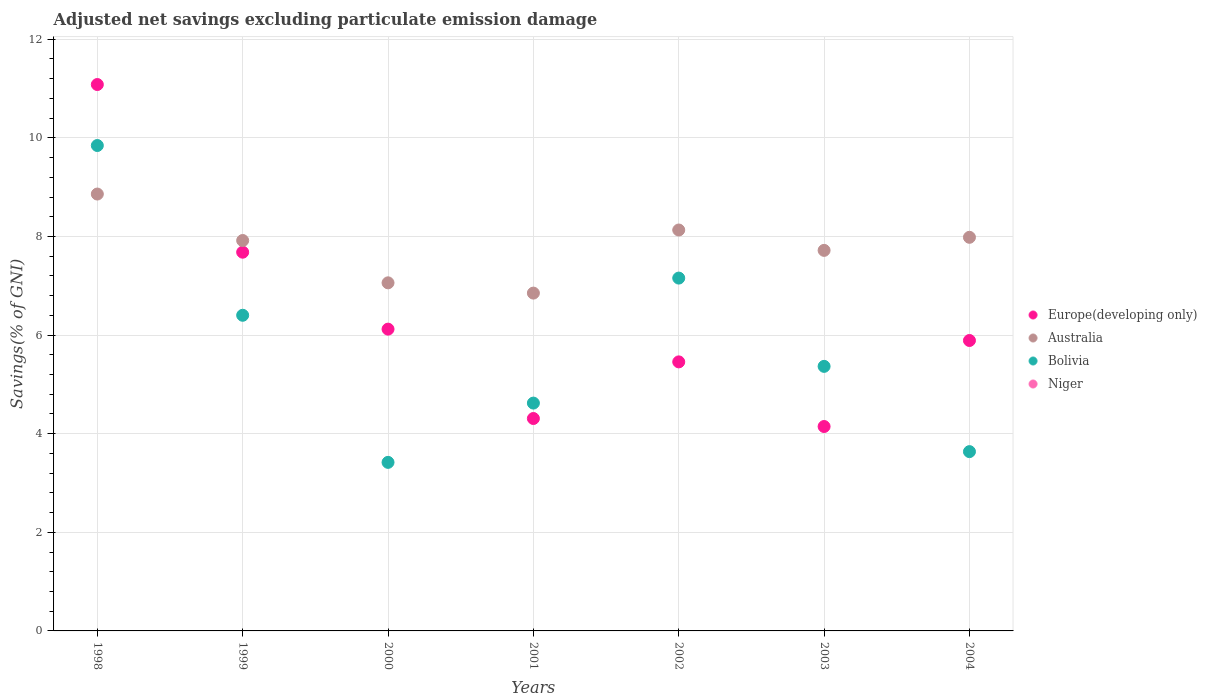How many different coloured dotlines are there?
Ensure brevity in your answer.  3. Is the number of dotlines equal to the number of legend labels?
Provide a succinct answer. No. What is the adjusted net savings in Bolivia in 2002?
Your answer should be compact. 7.16. Across all years, what is the maximum adjusted net savings in Bolivia?
Give a very brief answer. 9.85. Across all years, what is the minimum adjusted net savings in Bolivia?
Offer a terse response. 3.42. In which year was the adjusted net savings in Europe(developing only) maximum?
Your answer should be compact. 1998. What is the difference between the adjusted net savings in Bolivia in 1998 and that in 1999?
Offer a very short reply. 3.44. What is the difference between the adjusted net savings in Europe(developing only) in 1998 and the adjusted net savings in Bolivia in 2001?
Your response must be concise. 6.46. What is the average adjusted net savings in Europe(developing only) per year?
Your answer should be very brief. 6.38. In the year 2001, what is the difference between the adjusted net savings in Bolivia and adjusted net savings in Europe(developing only)?
Offer a very short reply. 0.31. What is the ratio of the adjusted net savings in Australia in 1999 to that in 2004?
Ensure brevity in your answer.  0.99. Is the adjusted net savings in Europe(developing only) in 2000 less than that in 2002?
Offer a very short reply. No. Is the difference between the adjusted net savings in Bolivia in 1998 and 2002 greater than the difference between the adjusted net savings in Europe(developing only) in 1998 and 2002?
Offer a terse response. No. What is the difference between the highest and the second highest adjusted net savings in Bolivia?
Offer a very short reply. 2.69. What is the difference between the highest and the lowest adjusted net savings in Europe(developing only)?
Give a very brief answer. 6.94. Does the adjusted net savings in Europe(developing only) monotonically increase over the years?
Make the answer very short. No. Is the adjusted net savings in Niger strictly greater than the adjusted net savings in Bolivia over the years?
Your response must be concise. No. How many dotlines are there?
Offer a terse response. 3. How many years are there in the graph?
Offer a terse response. 7. Does the graph contain any zero values?
Ensure brevity in your answer.  Yes. Where does the legend appear in the graph?
Your response must be concise. Center right. How many legend labels are there?
Provide a succinct answer. 4. How are the legend labels stacked?
Give a very brief answer. Vertical. What is the title of the graph?
Offer a very short reply. Adjusted net savings excluding particulate emission damage. What is the label or title of the Y-axis?
Provide a succinct answer. Savings(% of GNI). What is the Savings(% of GNI) in Europe(developing only) in 1998?
Provide a succinct answer. 11.08. What is the Savings(% of GNI) of Australia in 1998?
Provide a short and direct response. 8.86. What is the Savings(% of GNI) of Bolivia in 1998?
Make the answer very short. 9.85. What is the Savings(% of GNI) in Europe(developing only) in 1999?
Offer a terse response. 7.68. What is the Savings(% of GNI) in Australia in 1999?
Offer a very short reply. 7.92. What is the Savings(% of GNI) of Bolivia in 1999?
Provide a short and direct response. 6.4. What is the Savings(% of GNI) in Niger in 1999?
Make the answer very short. 0. What is the Savings(% of GNI) in Europe(developing only) in 2000?
Offer a terse response. 6.12. What is the Savings(% of GNI) in Australia in 2000?
Make the answer very short. 7.06. What is the Savings(% of GNI) of Bolivia in 2000?
Make the answer very short. 3.42. What is the Savings(% of GNI) of Niger in 2000?
Your response must be concise. 0. What is the Savings(% of GNI) in Europe(developing only) in 2001?
Keep it short and to the point. 4.31. What is the Savings(% of GNI) in Australia in 2001?
Your response must be concise. 6.85. What is the Savings(% of GNI) of Bolivia in 2001?
Offer a very short reply. 4.62. What is the Savings(% of GNI) of Europe(developing only) in 2002?
Keep it short and to the point. 5.46. What is the Savings(% of GNI) of Australia in 2002?
Your answer should be compact. 8.13. What is the Savings(% of GNI) in Bolivia in 2002?
Your answer should be compact. 7.16. What is the Savings(% of GNI) in Niger in 2002?
Your answer should be very brief. 0. What is the Savings(% of GNI) in Europe(developing only) in 2003?
Offer a very short reply. 4.15. What is the Savings(% of GNI) of Australia in 2003?
Your answer should be very brief. 7.72. What is the Savings(% of GNI) in Bolivia in 2003?
Give a very brief answer. 5.37. What is the Savings(% of GNI) of Niger in 2003?
Provide a short and direct response. 0. What is the Savings(% of GNI) in Europe(developing only) in 2004?
Give a very brief answer. 5.89. What is the Savings(% of GNI) of Australia in 2004?
Keep it short and to the point. 7.98. What is the Savings(% of GNI) of Bolivia in 2004?
Provide a succinct answer. 3.64. What is the Savings(% of GNI) in Niger in 2004?
Provide a succinct answer. 0. Across all years, what is the maximum Savings(% of GNI) in Europe(developing only)?
Your response must be concise. 11.08. Across all years, what is the maximum Savings(% of GNI) in Australia?
Your answer should be very brief. 8.86. Across all years, what is the maximum Savings(% of GNI) of Bolivia?
Keep it short and to the point. 9.85. Across all years, what is the minimum Savings(% of GNI) of Europe(developing only)?
Your response must be concise. 4.15. Across all years, what is the minimum Savings(% of GNI) in Australia?
Your answer should be compact. 6.85. Across all years, what is the minimum Savings(% of GNI) in Bolivia?
Provide a short and direct response. 3.42. What is the total Savings(% of GNI) in Europe(developing only) in the graph?
Make the answer very short. 44.69. What is the total Savings(% of GNI) of Australia in the graph?
Your answer should be compact. 54.52. What is the total Savings(% of GNI) in Bolivia in the graph?
Make the answer very short. 40.45. What is the difference between the Savings(% of GNI) in Europe(developing only) in 1998 and that in 1999?
Your answer should be compact. 3.4. What is the difference between the Savings(% of GNI) of Australia in 1998 and that in 1999?
Offer a very short reply. 0.94. What is the difference between the Savings(% of GNI) of Bolivia in 1998 and that in 1999?
Ensure brevity in your answer.  3.44. What is the difference between the Savings(% of GNI) of Europe(developing only) in 1998 and that in 2000?
Your answer should be compact. 4.96. What is the difference between the Savings(% of GNI) in Australia in 1998 and that in 2000?
Give a very brief answer. 1.8. What is the difference between the Savings(% of GNI) in Bolivia in 1998 and that in 2000?
Give a very brief answer. 6.43. What is the difference between the Savings(% of GNI) in Europe(developing only) in 1998 and that in 2001?
Give a very brief answer. 6.77. What is the difference between the Savings(% of GNI) of Australia in 1998 and that in 2001?
Offer a very short reply. 2.01. What is the difference between the Savings(% of GNI) of Bolivia in 1998 and that in 2001?
Give a very brief answer. 5.22. What is the difference between the Savings(% of GNI) in Europe(developing only) in 1998 and that in 2002?
Ensure brevity in your answer.  5.63. What is the difference between the Savings(% of GNI) in Australia in 1998 and that in 2002?
Your answer should be very brief. 0.73. What is the difference between the Savings(% of GNI) of Bolivia in 1998 and that in 2002?
Make the answer very short. 2.69. What is the difference between the Savings(% of GNI) in Europe(developing only) in 1998 and that in 2003?
Your answer should be very brief. 6.94. What is the difference between the Savings(% of GNI) in Australia in 1998 and that in 2003?
Your answer should be compact. 1.14. What is the difference between the Savings(% of GNI) in Bolivia in 1998 and that in 2003?
Provide a succinct answer. 4.48. What is the difference between the Savings(% of GNI) in Europe(developing only) in 1998 and that in 2004?
Your answer should be compact. 5.19. What is the difference between the Savings(% of GNI) of Australia in 1998 and that in 2004?
Give a very brief answer. 0.88. What is the difference between the Savings(% of GNI) of Bolivia in 1998 and that in 2004?
Ensure brevity in your answer.  6.21. What is the difference between the Savings(% of GNI) of Europe(developing only) in 1999 and that in 2000?
Keep it short and to the point. 1.56. What is the difference between the Savings(% of GNI) of Australia in 1999 and that in 2000?
Provide a succinct answer. 0.86. What is the difference between the Savings(% of GNI) of Bolivia in 1999 and that in 2000?
Your answer should be very brief. 2.98. What is the difference between the Savings(% of GNI) of Europe(developing only) in 1999 and that in 2001?
Provide a succinct answer. 3.37. What is the difference between the Savings(% of GNI) in Australia in 1999 and that in 2001?
Keep it short and to the point. 1.07. What is the difference between the Savings(% of GNI) in Bolivia in 1999 and that in 2001?
Your answer should be very brief. 1.78. What is the difference between the Savings(% of GNI) of Europe(developing only) in 1999 and that in 2002?
Provide a short and direct response. 2.22. What is the difference between the Savings(% of GNI) in Australia in 1999 and that in 2002?
Make the answer very short. -0.21. What is the difference between the Savings(% of GNI) in Bolivia in 1999 and that in 2002?
Offer a very short reply. -0.75. What is the difference between the Savings(% of GNI) in Europe(developing only) in 1999 and that in 2003?
Keep it short and to the point. 3.54. What is the difference between the Savings(% of GNI) of Australia in 1999 and that in 2003?
Your answer should be very brief. 0.2. What is the difference between the Savings(% of GNI) of Bolivia in 1999 and that in 2003?
Your answer should be very brief. 1.04. What is the difference between the Savings(% of GNI) of Europe(developing only) in 1999 and that in 2004?
Offer a terse response. 1.79. What is the difference between the Savings(% of GNI) of Australia in 1999 and that in 2004?
Provide a succinct answer. -0.06. What is the difference between the Savings(% of GNI) in Bolivia in 1999 and that in 2004?
Give a very brief answer. 2.77. What is the difference between the Savings(% of GNI) of Europe(developing only) in 2000 and that in 2001?
Provide a succinct answer. 1.81. What is the difference between the Savings(% of GNI) of Australia in 2000 and that in 2001?
Offer a very short reply. 0.21. What is the difference between the Savings(% of GNI) in Bolivia in 2000 and that in 2001?
Offer a very short reply. -1.2. What is the difference between the Savings(% of GNI) of Europe(developing only) in 2000 and that in 2002?
Your response must be concise. 0.66. What is the difference between the Savings(% of GNI) in Australia in 2000 and that in 2002?
Ensure brevity in your answer.  -1.07. What is the difference between the Savings(% of GNI) of Bolivia in 2000 and that in 2002?
Your response must be concise. -3.74. What is the difference between the Savings(% of GNI) of Europe(developing only) in 2000 and that in 2003?
Provide a succinct answer. 1.98. What is the difference between the Savings(% of GNI) in Australia in 2000 and that in 2003?
Your answer should be very brief. -0.66. What is the difference between the Savings(% of GNI) of Bolivia in 2000 and that in 2003?
Provide a succinct answer. -1.95. What is the difference between the Savings(% of GNI) in Europe(developing only) in 2000 and that in 2004?
Your response must be concise. 0.23. What is the difference between the Savings(% of GNI) in Australia in 2000 and that in 2004?
Make the answer very short. -0.92. What is the difference between the Savings(% of GNI) in Bolivia in 2000 and that in 2004?
Your response must be concise. -0.22. What is the difference between the Savings(% of GNI) in Europe(developing only) in 2001 and that in 2002?
Ensure brevity in your answer.  -1.15. What is the difference between the Savings(% of GNI) of Australia in 2001 and that in 2002?
Keep it short and to the point. -1.28. What is the difference between the Savings(% of GNI) in Bolivia in 2001 and that in 2002?
Offer a terse response. -2.54. What is the difference between the Savings(% of GNI) of Europe(developing only) in 2001 and that in 2003?
Keep it short and to the point. 0.16. What is the difference between the Savings(% of GNI) of Australia in 2001 and that in 2003?
Offer a terse response. -0.87. What is the difference between the Savings(% of GNI) of Bolivia in 2001 and that in 2003?
Your answer should be very brief. -0.74. What is the difference between the Savings(% of GNI) of Europe(developing only) in 2001 and that in 2004?
Make the answer very short. -1.58. What is the difference between the Savings(% of GNI) in Australia in 2001 and that in 2004?
Provide a short and direct response. -1.13. What is the difference between the Savings(% of GNI) in Bolivia in 2001 and that in 2004?
Provide a short and direct response. 0.98. What is the difference between the Savings(% of GNI) of Europe(developing only) in 2002 and that in 2003?
Provide a short and direct response. 1.31. What is the difference between the Savings(% of GNI) in Australia in 2002 and that in 2003?
Keep it short and to the point. 0.41. What is the difference between the Savings(% of GNI) in Bolivia in 2002 and that in 2003?
Your answer should be very brief. 1.79. What is the difference between the Savings(% of GNI) in Europe(developing only) in 2002 and that in 2004?
Your answer should be compact. -0.43. What is the difference between the Savings(% of GNI) of Australia in 2002 and that in 2004?
Offer a terse response. 0.15. What is the difference between the Savings(% of GNI) in Bolivia in 2002 and that in 2004?
Your response must be concise. 3.52. What is the difference between the Savings(% of GNI) in Europe(developing only) in 2003 and that in 2004?
Make the answer very short. -1.74. What is the difference between the Savings(% of GNI) of Australia in 2003 and that in 2004?
Provide a short and direct response. -0.27. What is the difference between the Savings(% of GNI) of Bolivia in 2003 and that in 2004?
Your answer should be compact. 1.73. What is the difference between the Savings(% of GNI) of Europe(developing only) in 1998 and the Savings(% of GNI) of Australia in 1999?
Provide a short and direct response. 3.16. What is the difference between the Savings(% of GNI) of Europe(developing only) in 1998 and the Savings(% of GNI) of Bolivia in 1999?
Offer a very short reply. 4.68. What is the difference between the Savings(% of GNI) of Australia in 1998 and the Savings(% of GNI) of Bolivia in 1999?
Your answer should be compact. 2.46. What is the difference between the Savings(% of GNI) in Europe(developing only) in 1998 and the Savings(% of GNI) in Australia in 2000?
Keep it short and to the point. 4.02. What is the difference between the Savings(% of GNI) in Europe(developing only) in 1998 and the Savings(% of GNI) in Bolivia in 2000?
Your answer should be very brief. 7.66. What is the difference between the Savings(% of GNI) of Australia in 1998 and the Savings(% of GNI) of Bolivia in 2000?
Keep it short and to the point. 5.44. What is the difference between the Savings(% of GNI) of Europe(developing only) in 1998 and the Savings(% of GNI) of Australia in 2001?
Offer a very short reply. 4.23. What is the difference between the Savings(% of GNI) in Europe(developing only) in 1998 and the Savings(% of GNI) in Bolivia in 2001?
Provide a succinct answer. 6.46. What is the difference between the Savings(% of GNI) in Australia in 1998 and the Savings(% of GNI) in Bolivia in 2001?
Keep it short and to the point. 4.24. What is the difference between the Savings(% of GNI) of Europe(developing only) in 1998 and the Savings(% of GNI) of Australia in 2002?
Ensure brevity in your answer.  2.95. What is the difference between the Savings(% of GNI) of Europe(developing only) in 1998 and the Savings(% of GNI) of Bolivia in 2002?
Keep it short and to the point. 3.93. What is the difference between the Savings(% of GNI) of Australia in 1998 and the Savings(% of GNI) of Bolivia in 2002?
Your answer should be very brief. 1.7. What is the difference between the Savings(% of GNI) of Europe(developing only) in 1998 and the Savings(% of GNI) of Australia in 2003?
Provide a short and direct response. 3.36. What is the difference between the Savings(% of GNI) of Europe(developing only) in 1998 and the Savings(% of GNI) of Bolivia in 2003?
Your answer should be very brief. 5.72. What is the difference between the Savings(% of GNI) of Australia in 1998 and the Savings(% of GNI) of Bolivia in 2003?
Keep it short and to the point. 3.5. What is the difference between the Savings(% of GNI) of Europe(developing only) in 1998 and the Savings(% of GNI) of Australia in 2004?
Provide a short and direct response. 3.1. What is the difference between the Savings(% of GNI) of Europe(developing only) in 1998 and the Savings(% of GNI) of Bolivia in 2004?
Offer a very short reply. 7.45. What is the difference between the Savings(% of GNI) in Australia in 1998 and the Savings(% of GNI) in Bolivia in 2004?
Make the answer very short. 5.22. What is the difference between the Savings(% of GNI) of Europe(developing only) in 1999 and the Savings(% of GNI) of Australia in 2000?
Keep it short and to the point. 0.62. What is the difference between the Savings(% of GNI) of Europe(developing only) in 1999 and the Savings(% of GNI) of Bolivia in 2000?
Offer a very short reply. 4.26. What is the difference between the Savings(% of GNI) in Australia in 1999 and the Savings(% of GNI) in Bolivia in 2000?
Your response must be concise. 4.5. What is the difference between the Savings(% of GNI) in Europe(developing only) in 1999 and the Savings(% of GNI) in Australia in 2001?
Ensure brevity in your answer.  0.83. What is the difference between the Savings(% of GNI) in Europe(developing only) in 1999 and the Savings(% of GNI) in Bolivia in 2001?
Make the answer very short. 3.06. What is the difference between the Savings(% of GNI) of Australia in 1999 and the Savings(% of GNI) of Bolivia in 2001?
Keep it short and to the point. 3.3. What is the difference between the Savings(% of GNI) of Europe(developing only) in 1999 and the Savings(% of GNI) of Australia in 2002?
Your response must be concise. -0.45. What is the difference between the Savings(% of GNI) in Europe(developing only) in 1999 and the Savings(% of GNI) in Bolivia in 2002?
Provide a short and direct response. 0.53. What is the difference between the Savings(% of GNI) in Australia in 1999 and the Savings(% of GNI) in Bolivia in 2002?
Keep it short and to the point. 0.76. What is the difference between the Savings(% of GNI) of Europe(developing only) in 1999 and the Savings(% of GNI) of Australia in 2003?
Your answer should be very brief. -0.04. What is the difference between the Savings(% of GNI) in Europe(developing only) in 1999 and the Savings(% of GNI) in Bolivia in 2003?
Provide a succinct answer. 2.32. What is the difference between the Savings(% of GNI) in Australia in 1999 and the Savings(% of GNI) in Bolivia in 2003?
Your answer should be compact. 2.55. What is the difference between the Savings(% of GNI) of Europe(developing only) in 1999 and the Savings(% of GNI) of Australia in 2004?
Offer a terse response. -0.3. What is the difference between the Savings(% of GNI) in Europe(developing only) in 1999 and the Savings(% of GNI) in Bolivia in 2004?
Keep it short and to the point. 4.04. What is the difference between the Savings(% of GNI) of Australia in 1999 and the Savings(% of GNI) of Bolivia in 2004?
Your response must be concise. 4.28. What is the difference between the Savings(% of GNI) of Europe(developing only) in 2000 and the Savings(% of GNI) of Australia in 2001?
Your response must be concise. -0.73. What is the difference between the Savings(% of GNI) of Europe(developing only) in 2000 and the Savings(% of GNI) of Bolivia in 2001?
Offer a terse response. 1.5. What is the difference between the Savings(% of GNI) of Australia in 2000 and the Savings(% of GNI) of Bolivia in 2001?
Your answer should be compact. 2.44. What is the difference between the Savings(% of GNI) in Europe(developing only) in 2000 and the Savings(% of GNI) in Australia in 2002?
Keep it short and to the point. -2.01. What is the difference between the Savings(% of GNI) of Europe(developing only) in 2000 and the Savings(% of GNI) of Bolivia in 2002?
Your answer should be very brief. -1.04. What is the difference between the Savings(% of GNI) in Australia in 2000 and the Savings(% of GNI) in Bolivia in 2002?
Offer a terse response. -0.1. What is the difference between the Savings(% of GNI) of Europe(developing only) in 2000 and the Savings(% of GNI) of Australia in 2003?
Provide a succinct answer. -1.6. What is the difference between the Savings(% of GNI) of Europe(developing only) in 2000 and the Savings(% of GNI) of Bolivia in 2003?
Provide a short and direct response. 0.76. What is the difference between the Savings(% of GNI) in Australia in 2000 and the Savings(% of GNI) in Bolivia in 2003?
Your answer should be compact. 1.69. What is the difference between the Savings(% of GNI) of Europe(developing only) in 2000 and the Savings(% of GNI) of Australia in 2004?
Your response must be concise. -1.86. What is the difference between the Savings(% of GNI) in Europe(developing only) in 2000 and the Savings(% of GNI) in Bolivia in 2004?
Offer a terse response. 2.48. What is the difference between the Savings(% of GNI) of Australia in 2000 and the Savings(% of GNI) of Bolivia in 2004?
Your answer should be compact. 3.42. What is the difference between the Savings(% of GNI) of Europe(developing only) in 2001 and the Savings(% of GNI) of Australia in 2002?
Give a very brief answer. -3.82. What is the difference between the Savings(% of GNI) in Europe(developing only) in 2001 and the Savings(% of GNI) in Bolivia in 2002?
Your response must be concise. -2.85. What is the difference between the Savings(% of GNI) of Australia in 2001 and the Savings(% of GNI) of Bolivia in 2002?
Ensure brevity in your answer.  -0.3. What is the difference between the Savings(% of GNI) of Europe(developing only) in 2001 and the Savings(% of GNI) of Australia in 2003?
Ensure brevity in your answer.  -3.41. What is the difference between the Savings(% of GNI) in Europe(developing only) in 2001 and the Savings(% of GNI) in Bolivia in 2003?
Make the answer very short. -1.06. What is the difference between the Savings(% of GNI) in Australia in 2001 and the Savings(% of GNI) in Bolivia in 2003?
Make the answer very short. 1.49. What is the difference between the Savings(% of GNI) of Europe(developing only) in 2001 and the Savings(% of GNI) of Australia in 2004?
Keep it short and to the point. -3.67. What is the difference between the Savings(% of GNI) of Europe(developing only) in 2001 and the Savings(% of GNI) of Bolivia in 2004?
Offer a terse response. 0.67. What is the difference between the Savings(% of GNI) in Australia in 2001 and the Savings(% of GNI) in Bolivia in 2004?
Provide a succinct answer. 3.22. What is the difference between the Savings(% of GNI) in Europe(developing only) in 2002 and the Savings(% of GNI) in Australia in 2003?
Offer a very short reply. -2.26. What is the difference between the Savings(% of GNI) of Europe(developing only) in 2002 and the Savings(% of GNI) of Bolivia in 2003?
Provide a succinct answer. 0.09. What is the difference between the Savings(% of GNI) of Australia in 2002 and the Savings(% of GNI) of Bolivia in 2003?
Your answer should be very brief. 2.77. What is the difference between the Savings(% of GNI) in Europe(developing only) in 2002 and the Savings(% of GNI) in Australia in 2004?
Make the answer very short. -2.53. What is the difference between the Savings(% of GNI) in Europe(developing only) in 2002 and the Savings(% of GNI) in Bolivia in 2004?
Offer a very short reply. 1.82. What is the difference between the Savings(% of GNI) of Australia in 2002 and the Savings(% of GNI) of Bolivia in 2004?
Your answer should be very brief. 4.49. What is the difference between the Savings(% of GNI) of Europe(developing only) in 2003 and the Savings(% of GNI) of Australia in 2004?
Provide a short and direct response. -3.84. What is the difference between the Savings(% of GNI) in Europe(developing only) in 2003 and the Savings(% of GNI) in Bolivia in 2004?
Ensure brevity in your answer.  0.51. What is the difference between the Savings(% of GNI) of Australia in 2003 and the Savings(% of GNI) of Bolivia in 2004?
Offer a very short reply. 4.08. What is the average Savings(% of GNI) of Europe(developing only) per year?
Your answer should be very brief. 6.38. What is the average Savings(% of GNI) of Australia per year?
Provide a succinct answer. 7.79. What is the average Savings(% of GNI) in Bolivia per year?
Offer a very short reply. 5.78. In the year 1998, what is the difference between the Savings(% of GNI) of Europe(developing only) and Savings(% of GNI) of Australia?
Provide a succinct answer. 2.22. In the year 1998, what is the difference between the Savings(% of GNI) in Europe(developing only) and Savings(% of GNI) in Bolivia?
Make the answer very short. 1.24. In the year 1998, what is the difference between the Savings(% of GNI) of Australia and Savings(% of GNI) of Bolivia?
Offer a terse response. -0.98. In the year 1999, what is the difference between the Savings(% of GNI) in Europe(developing only) and Savings(% of GNI) in Australia?
Provide a short and direct response. -0.24. In the year 1999, what is the difference between the Savings(% of GNI) of Europe(developing only) and Savings(% of GNI) of Bolivia?
Your answer should be compact. 1.28. In the year 1999, what is the difference between the Savings(% of GNI) of Australia and Savings(% of GNI) of Bolivia?
Your answer should be compact. 1.52. In the year 2000, what is the difference between the Savings(% of GNI) in Europe(developing only) and Savings(% of GNI) in Australia?
Your answer should be very brief. -0.94. In the year 2000, what is the difference between the Savings(% of GNI) in Europe(developing only) and Savings(% of GNI) in Bolivia?
Offer a terse response. 2.7. In the year 2000, what is the difference between the Savings(% of GNI) in Australia and Savings(% of GNI) in Bolivia?
Provide a succinct answer. 3.64. In the year 2001, what is the difference between the Savings(% of GNI) in Europe(developing only) and Savings(% of GNI) in Australia?
Your response must be concise. -2.54. In the year 2001, what is the difference between the Savings(% of GNI) of Europe(developing only) and Savings(% of GNI) of Bolivia?
Give a very brief answer. -0.31. In the year 2001, what is the difference between the Savings(% of GNI) in Australia and Savings(% of GNI) in Bolivia?
Provide a short and direct response. 2.23. In the year 2002, what is the difference between the Savings(% of GNI) in Europe(developing only) and Savings(% of GNI) in Australia?
Keep it short and to the point. -2.67. In the year 2002, what is the difference between the Savings(% of GNI) in Europe(developing only) and Savings(% of GNI) in Bolivia?
Offer a very short reply. -1.7. In the year 2002, what is the difference between the Savings(% of GNI) in Australia and Savings(% of GNI) in Bolivia?
Provide a short and direct response. 0.98. In the year 2003, what is the difference between the Savings(% of GNI) of Europe(developing only) and Savings(% of GNI) of Australia?
Your response must be concise. -3.57. In the year 2003, what is the difference between the Savings(% of GNI) of Europe(developing only) and Savings(% of GNI) of Bolivia?
Make the answer very short. -1.22. In the year 2003, what is the difference between the Savings(% of GNI) in Australia and Savings(% of GNI) in Bolivia?
Provide a succinct answer. 2.35. In the year 2004, what is the difference between the Savings(% of GNI) of Europe(developing only) and Savings(% of GNI) of Australia?
Ensure brevity in your answer.  -2.09. In the year 2004, what is the difference between the Savings(% of GNI) in Europe(developing only) and Savings(% of GNI) in Bolivia?
Ensure brevity in your answer.  2.25. In the year 2004, what is the difference between the Savings(% of GNI) of Australia and Savings(% of GNI) of Bolivia?
Ensure brevity in your answer.  4.35. What is the ratio of the Savings(% of GNI) of Europe(developing only) in 1998 to that in 1999?
Provide a succinct answer. 1.44. What is the ratio of the Savings(% of GNI) of Australia in 1998 to that in 1999?
Keep it short and to the point. 1.12. What is the ratio of the Savings(% of GNI) in Bolivia in 1998 to that in 1999?
Make the answer very short. 1.54. What is the ratio of the Savings(% of GNI) of Europe(developing only) in 1998 to that in 2000?
Offer a terse response. 1.81. What is the ratio of the Savings(% of GNI) in Australia in 1998 to that in 2000?
Offer a terse response. 1.26. What is the ratio of the Savings(% of GNI) in Bolivia in 1998 to that in 2000?
Make the answer very short. 2.88. What is the ratio of the Savings(% of GNI) in Europe(developing only) in 1998 to that in 2001?
Your answer should be compact. 2.57. What is the ratio of the Savings(% of GNI) of Australia in 1998 to that in 2001?
Offer a very short reply. 1.29. What is the ratio of the Savings(% of GNI) of Bolivia in 1998 to that in 2001?
Make the answer very short. 2.13. What is the ratio of the Savings(% of GNI) in Europe(developing only) in 1998 to that in 2002?
Ensure brevity in your answer.  2.03. What is the ratio of the Savings(% of GNI) in Australia in 1998 to that in 2002?
Give a very brief answer. 1.09. What is the ratio of the Savings(% of GNI) in Bolivia in 1998 to that in 2002?
Your response must be concise. 1.38. What is the ratio of the Savings(% of GNI) in Europe(developing only) in 1998 to that in 2003?
Provide a succinct answer. 2.67. What is the ratio of the Savings(% of GNI) of Australia in 1998 to that in 2003?
Make the answer very short. 1.15. What is the ratio of the Savings(% of GNI) of Bolivia in 1998 to that in 2003?
Offer a terse response. 1.83. What is the ratio of the Savings(% of GNI) in Europe(developing only) in 1998 to that in 2004?
Provide a short and direct response. 1.88. What is the ratio of the Savings(% of GNI) in Australia in 1998 to that in 2004?
Keep it short and to the point. 1.11. What is the ratio of the Savings(% of GNI) of Bolivia in 1998 to that in 2004?
Offer a very short reply. 2.71. What is the ratio of the Savings(% of GNI) of Europe(developing only) in 1999 to that in 2000?
Give a very brief answer. 1.25. What is the ratio of the Savings(% of GNI) of Australia in 1999 to that in 2000?
Keep it short and to the point. 1.12. What is the ratio of the Savings(% of GNI) of Bolivia in 1999 to that in 2000?
Offer a very short reply. 1.87. What is the ratio of the Savings(% of GNI) of Europe(developing only) in 1999 to that in 2001?
Your response must be concise. 1.78. What is the ratio of the Savings(% of GNI) of Australia in 1999 to that in 2001?
Offer a terse response. 1.16. What is the ratio of the Savings(% of GNI) in Bolivia in 1999 to that in 2001?
Provide a short and direct response. 1.39. What is the ratio of the Savings(% of GNI) in Europe(developing only) in 1999 to that in 2002?
Provide a short and direct response. 1.41. What is the ratio of the Savings(% of GNI) of Australia in 1999 to that in 2002?
Give a very brief answer. 0.97. What is the ratio of the Savings(% of GNI) of Bolivia in 1999 to that in 2002?
Offer a terse response. 0.89. What is the ratio of the Savings(% of GNI) in Europe(developing only) in 1999 to that in 2003?
Give a very brief answer. 1.85. What is the ratio of the Savings(% of GNI) in Australia in 1999 to that in 2003?
Offer a terse response. 1.03. What is the ratio of the Savings(% of GNI) of Bolivia in 1999 to that in 2003?
Keep it short and to the point. 1.19. What is the ratio of the Savings(% of GNI) in Europe(developing only) in 1999 to that in 2004?
Give a very brief answer. 1.3. What is the ratio of the Savings(% of GNI) in Australia in 1999 to that in 2004?
Provide a succinct answer. 0.99. What is the ratio of the Savings(% of GNI) in Bolivia in 1999 to that in 2004?
Provide a short and direct response. 1.76. What is the ratio of the Savings(% of GNI) of Europe(developing only) in 2000 to that in 2001?
Ensure brevity in your answer.  1.42. What is the ratio of the Savings(% of GNI) of Australia in 2000 to that in 2001?
Offer a very short reply. 1.03. What is the ratio of the Savings(% of GNI) in Bolivia in 2000 to that in 2001?
Provide a short and direct response. 0.74. What is the ratio of the Savings(% of GNI) of Europe(developing only) in 2000 to that in 2002?
Offer a terse response. 1.12. What is the ratio of the Savings(% of GNI) of Australia in 2000 to that in 2002?
Provide a short and direct response. 0.87. What is the ratio of the Savings(% of GNI) in Bolivia in 2000 to that in 2002?
Make the answer very short. 0.48. What is the ratio of the Savings(% of GNI) of Europe(developing only) in 2000 to that in 2003?
Make the answer very short. 1.48. What is the ratio of the Savings(% of GNI) of Australia in 2000 to that in 2003?
Offer a terse response. 0.91. What is the ratio of the Savings(% of GNI) in Bolivia in 2000 to that in 2003?
Provide a succinct answer. 0.64. What is the ratio of the Savings(% of GNI) of Europe(developing only) in 2000 to that in 2004?
Give a very brief answer. 1.04. What is the ratio of the Savings(% of GNI) in Australia in 2000 to that in 2004?
Provide a succinct answer. 0.88. What is the ratio of the Savings(% of GNI) of Bolivia in 2000 to that in 2004?
Provide a short and direct response. 0.94. What is the ratio of the Savings(% of GNI) of Europe(developing only) in 2001 to that in 2002?
Provide a short and direct response. 0.79. What is the ratio of the Savings(% of GNI) in Australia in 2001 to that in 2002?
Your answer should be very brief. 0.84. What is the ratio of the Savings(% of GNI) in Bolivia in 2001 to that in 2002?
Keep it short and to the point. 0.65. What is the ratio of the Savings(% of GNI) in Europe(developing only) in 2001 to that in 2003?
Ensure brevity in your answer.  1.04. What is the ratio of the Savings(% of GNI) in Australia in 2001 to that in 2003?
Ensure brevity in your answer.  0.89. What is the ratio of the Savings(% of GNI) in Bolivia in 2001 to that in 2003?
Provide a succinct answer. 0.86. What is the ratio of the Savings(% of GNI) of Europe(developing only) in 2001 to that in 2004?
Offer a very short reply. 0.73. What is the ratio of the Savings(% of GNI) in Australia in 2001 to that in 2004?
Ensure brevity in your answer.  0.86. What is the ratio of the Savings(% of GNI) of Bolivia in 2001 to that in 2004?
Offer a terse response. 1.27. What is the ratio of the Savings(% of GNI) of Europe(developing only) in 2002 to that in 2003?
Ensure brevity in your answer.  1.32. What is the ratio of the Savings(% of GNI) in Australia in 2002 to that in 2003?
Provide a short and direct response. 1.05. What is the ratio of the Savings(% of GNI) in Bolivia in 2002 to that in 2003?
Your response must be concise. 1.33. What is the ratio of the Savings(% of GNI) of Europe(developing only) in 2002 to that in 2004?
Your answer should be very brief. 0.93. What is the ratio of the Savings(% of GNI) of Australia in 2002 to that in 2004?
Ensure brevity in your answer.  1.02. What is the ratio of the Savings(% of GNI) in Bolivia in 2002 to that in 2004?
Provide a succinct answer. 1.97. What is the ratio of the Savings(% of GNI) in Europe(developing only) in 2003 to that in 2004?
Your answer should be very brief. 0.7. What is the ratio of the Savings(% of GNI) of Australia in 2003 to that in 2004?
Provide a succinct answer. 0.97. What is the ratio of the Savings(% of GNI) of Bolivia in 2003 to that in 2004?
Offer a terse response. 1.48. What is the difference between the highest and the second highest Savings(% of GNI) of Europe(developing only)?
Your response must be concise. 3.4. What is the difference between the highest and the second highest Savings(% of GNI) of Australia?
Offer a very short reply. 0.73. What is the difference between the highest and the second highest Savings(% of GNI) of Bolivia?
Offer a terse response. 2.69. What is the difference between the highest and the lowest Savings(% of GNI) of Europe(developing only)?
Your answer should be very brief. 6.94. What is the difference between the highest and the lowest Savings(% of GNI) of Australia?
Ensure brevity in your answer.  2.01. What is the difference between the highest and the lowest Savings(% of GNI) in Bolivia?
Offer a very short reply. 6.43. 